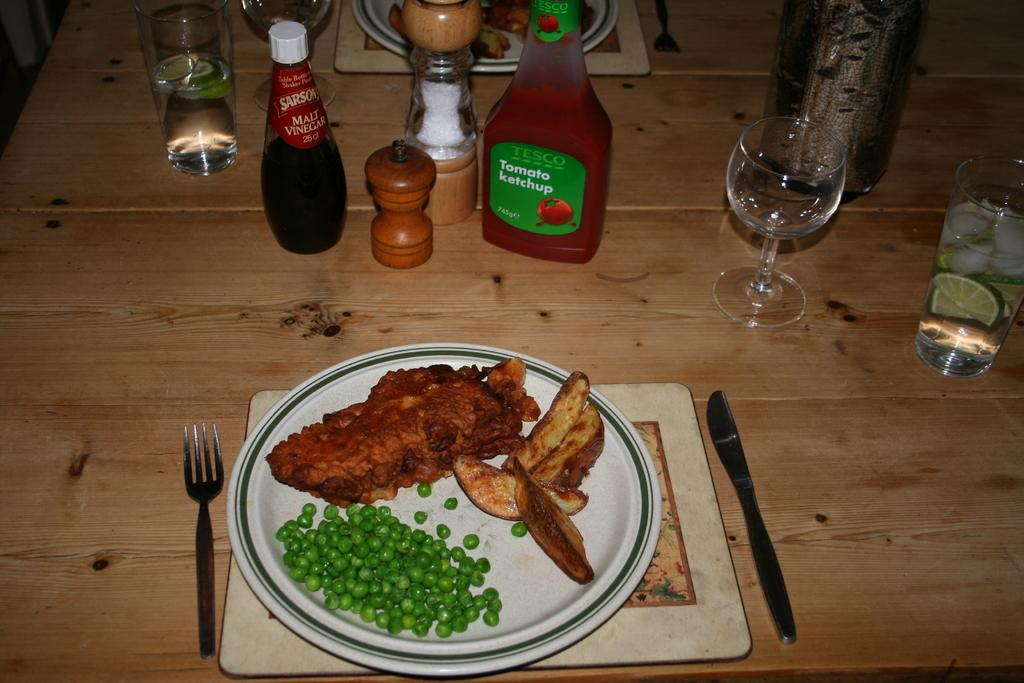What is on the plate in the image? There is food in a plate in the image. What utensil can be seen in the image? There is a fork in the image. What other utensil is present in the image? There is a knife in the image. What type of containers are visible in the image? There are glasses and bottles in the image. What advice does the food on the plate give to the fork in the image? There is no dialogue or communication between the food and the fork in the image, so it is not possible to determine any advice being given. 